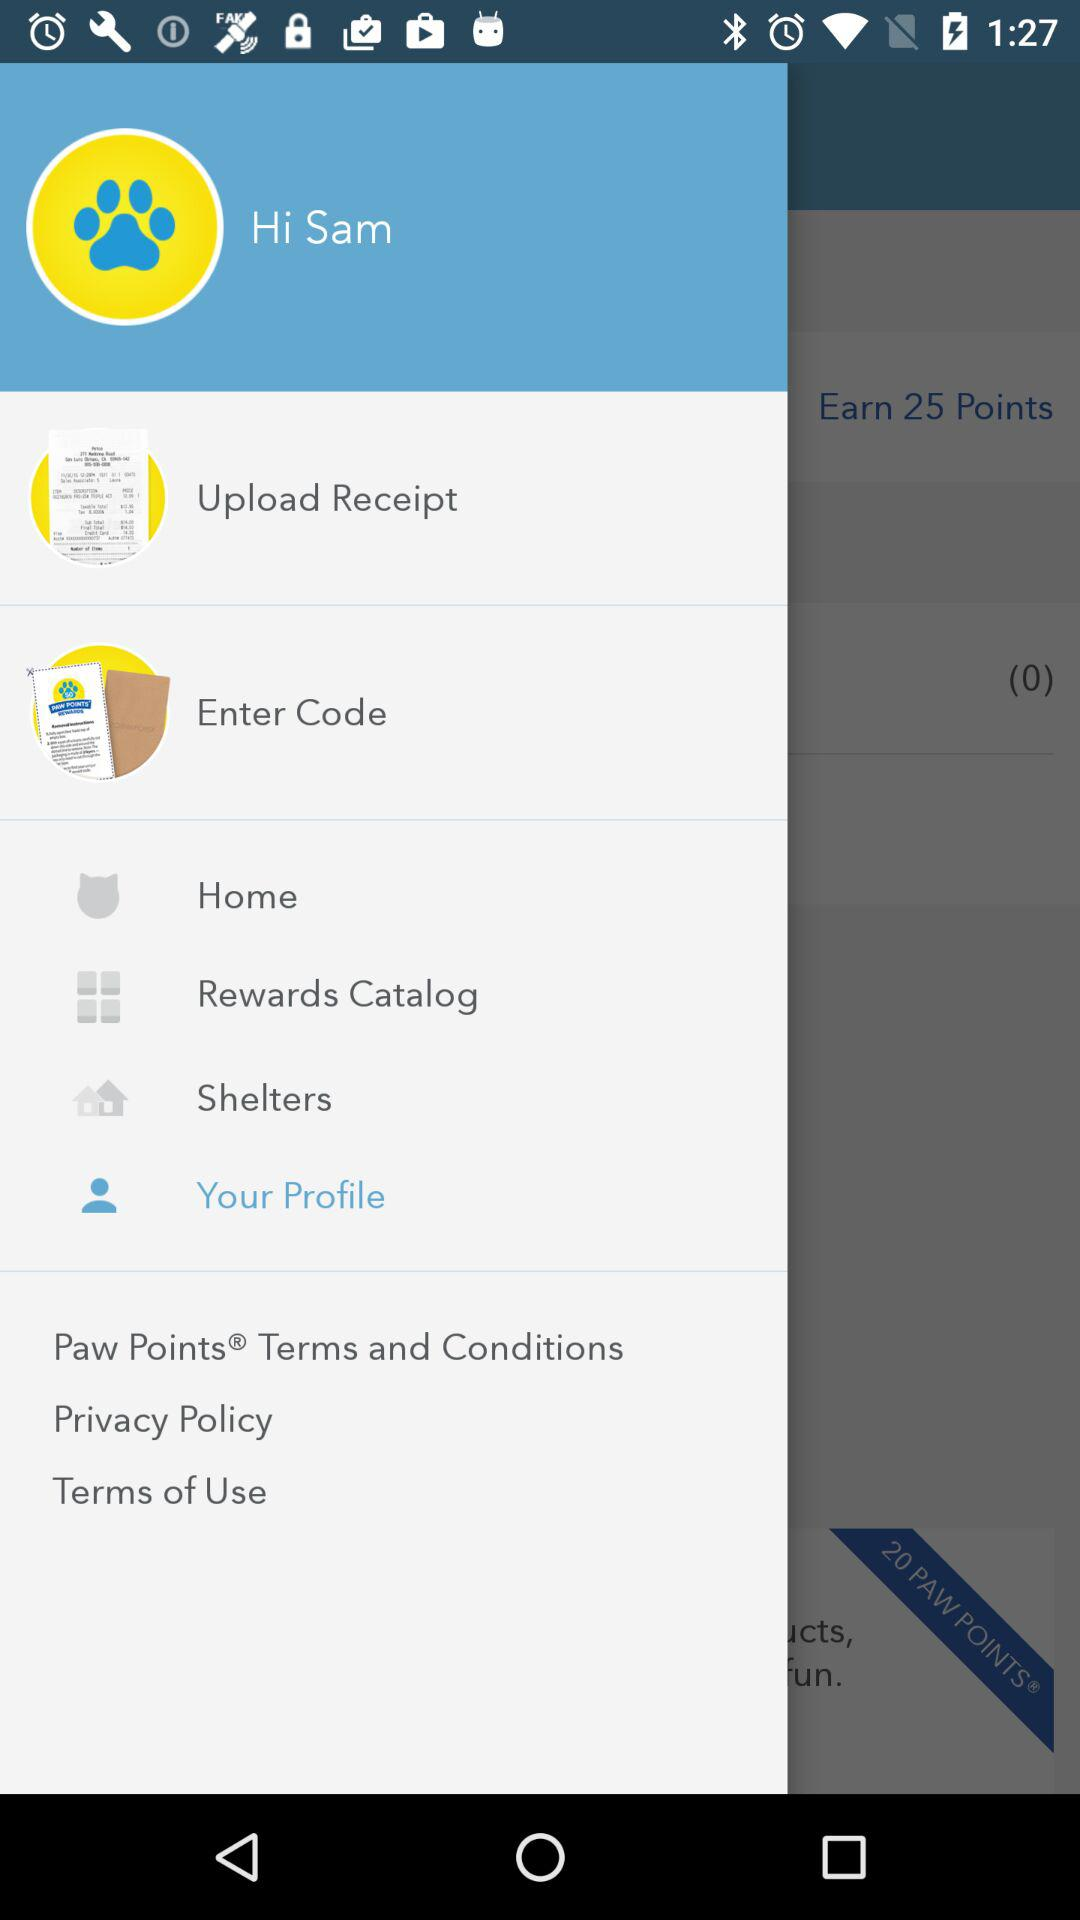Which receipts have been uploaded?
When the provided information is insufficient, respond with <no answer>. <no answer> 